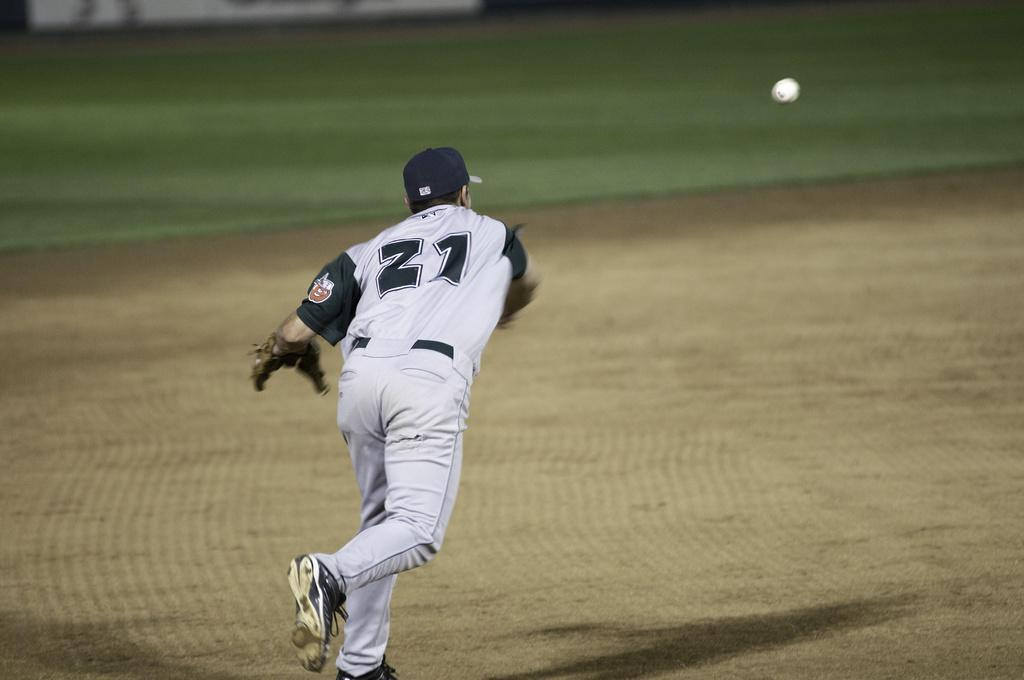<image>
Relay a brief, clear account of the picture shown. Player number 21 with the glove in his left hand is throwing the ball. 